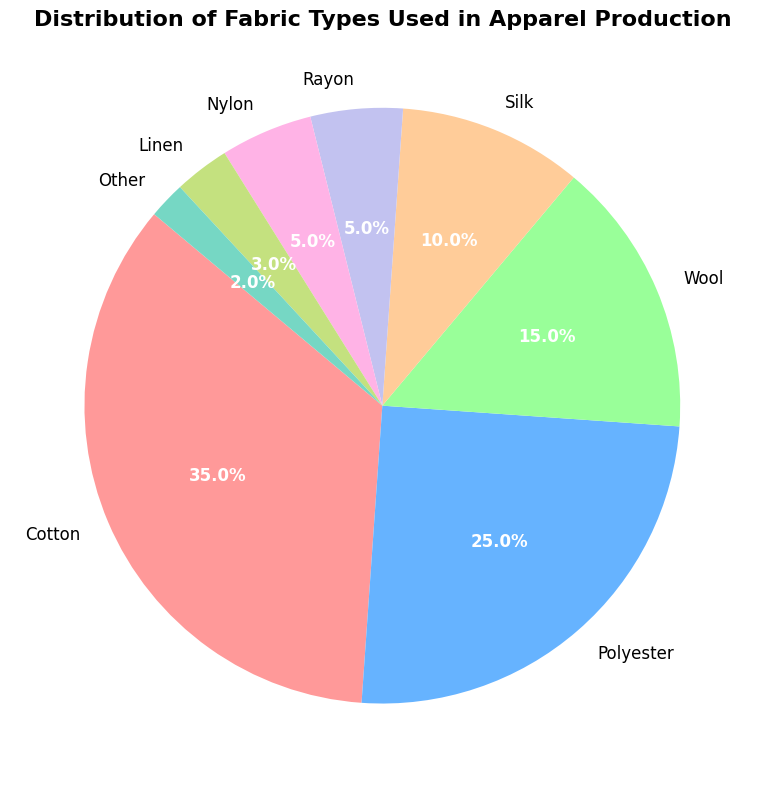What percentage of the fabrics used are made from Cotton and Wool combined? To find the combined percentage of Cotton and Wool fabrics used, sum up the individual percentages of Cotton and Wool from the pie chart. Cotton accounts for 35% and Wool accounts for 15%. Therefore, the combined percentage is 35% + 15% = 50%.
Answer: 50% Which fabric type has the smallest representation in the pie chart? To identify the fabric type with the smallest representation, look at the percentages shown in the pie chart. The 'Other' category has the smallest percentage representation at 2%.
Answer: Other How does the usage of Polyester compare to the usage of Silk? To compare the usage of Polyester and Silk, look at their individual percentages in the pie chart. Polyester is 25%, while Silk is 10%. Polyester usage is greater, and numerically, it is 25% - 10% = 15% more than Silk.
Answer: Polyester is used 15% more than Silk Is the combined usage of Rayon and Nylon greater than the usage of Wool? To determine this, sum up the percentages for Rayon and Nylon, then compare it to Wool's percentage. Rayon is 5% and Nylon is 5%, so their combined usage is 5% + 5% = 10%. Wool's usage is 15%, which is greater than the combined 10% of Rayon and Nylon.
Answer: No, Wool's usage is greater Which fabric type is represented by the green segment in the pie chart? According to the colors assigned in the pie chart, the green segment corresponds to Nylon.
Answer: Nylon What percentage of fabrics used are natural fibers (Cotton, Wool, Silk, Linen)? To find the percentage of natural fibers used, sum up the percentages of Cotton, Wool, Silk, and Linen. Cotton is 35%, Wool is 15%, Silk is 10%, and Linen is 3%. The combined total is 35% + 15% + 10% + 3% = 63%.
Answer: 63% How does the combined usage of Cotton and Polyester compare to the total usage of all other fabric types? Sum up the percentages of Cotton and Polyester, and then compare it to the total percentage of all other fabric types. Cotton is 35%, and Polyester is 25%, so their total is 35% + 25% = 60%. The total percentage for all other fabric types is 100% - (35% + 25%) = 100% - 60% = 40%. Cotton and Polyester's combined usage is greater.
Answer: Cotton and Polyester's combined usage is 20% greater Which fabric types together make up exactly half of the total fabric used? To determine which fabric types together make up exactly half, sum up the percentages starting with the highest until reaching or exceeding 50%. Cotton is 35%, and adding Polyester (25%) would give 35% + 25% = 60%, which exceeds half. Therefore, Cotton (35%) and Wool (15%) sum up to 35% + 15% = 50%.
Answer: Cotton and Wool What is the ratio of the usage of Rayon to Linen? The percentages of Rayon and Linen in the chart are 5% and 3%, respectively. The ratio of Rayon to Linen is 5:3.
Answer: 5:3 